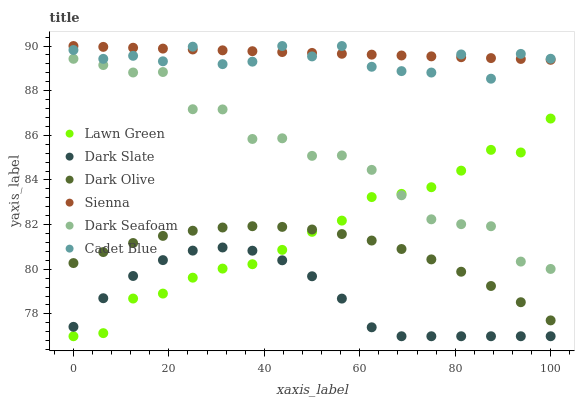Does Dark Slate have the minimum area under the curve?
Answer yes or no. Yes. Does Sienna have the maximum area under the curve?
Answer yes or no. Yes. Does Cadet Blue have the minimum area under the curve?
Answer yes or no. No. Does Cadet Blue have the maximum area under the curve?
Answer yes or no. No. Is Sienna the smoothest?
Answer yes or no. Yes. Is Cadet Blue the roughest?
Answer yes or no. Yes. Is Dark Olive the smoothest?
Answer yes or no. No. Is Dark Olive the roughest?
Answer yes or no. No. Does Lawn Green have the lowest value?
Answer yes or no. Yes. Does Cadet Blue have the lowest value?
Answer yes or no. No. Does Sienna have the highest value?
Answer yes or no. Yes. Does Dark Olive have the highest value?
Answer yes or no. No. Is Dark Seafoam less than Cadet Blue?
Answer yes or no. Yes. Is Cadet Blue greater than Dark Olive?
Answer yes or no. Yes. Does Lawn Green intersect Dark Seafoam?
Answer yes or no. Yes. Is Lawn Green less than Dark Seafoam?
Answer yes or no. No. Is Lawn Green greater than Dark Seafoam?
Answer yes or no. No. Does Dark Seafoam intersect Cadet Blue?
Answer yes or no. No. 